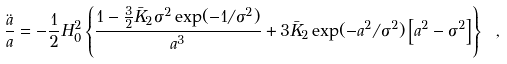<formula> <loc_0><loc_0><loc_500><loc_500>\frac { \ddot { a } } { a } = - \frac { 1 } { 2 } H _ { 0 } ^ { 2 } \left \{ \frac { 1 - \frac { 3 } { 2 } \bar { K } _ { 2 } \sigma ^ { 2 } \exp ( - 1 / \sigma ^ { 2 } ) } { a ^ { 3 } } + 3 \bar { K } _ { 2 } \exp ( - a ^ { 2 } / \sigma ^ { 2 } ) \left [ a ^ { 2 } - \sigma ^ { 2 } \right ] \right \} \ ,</formula> 